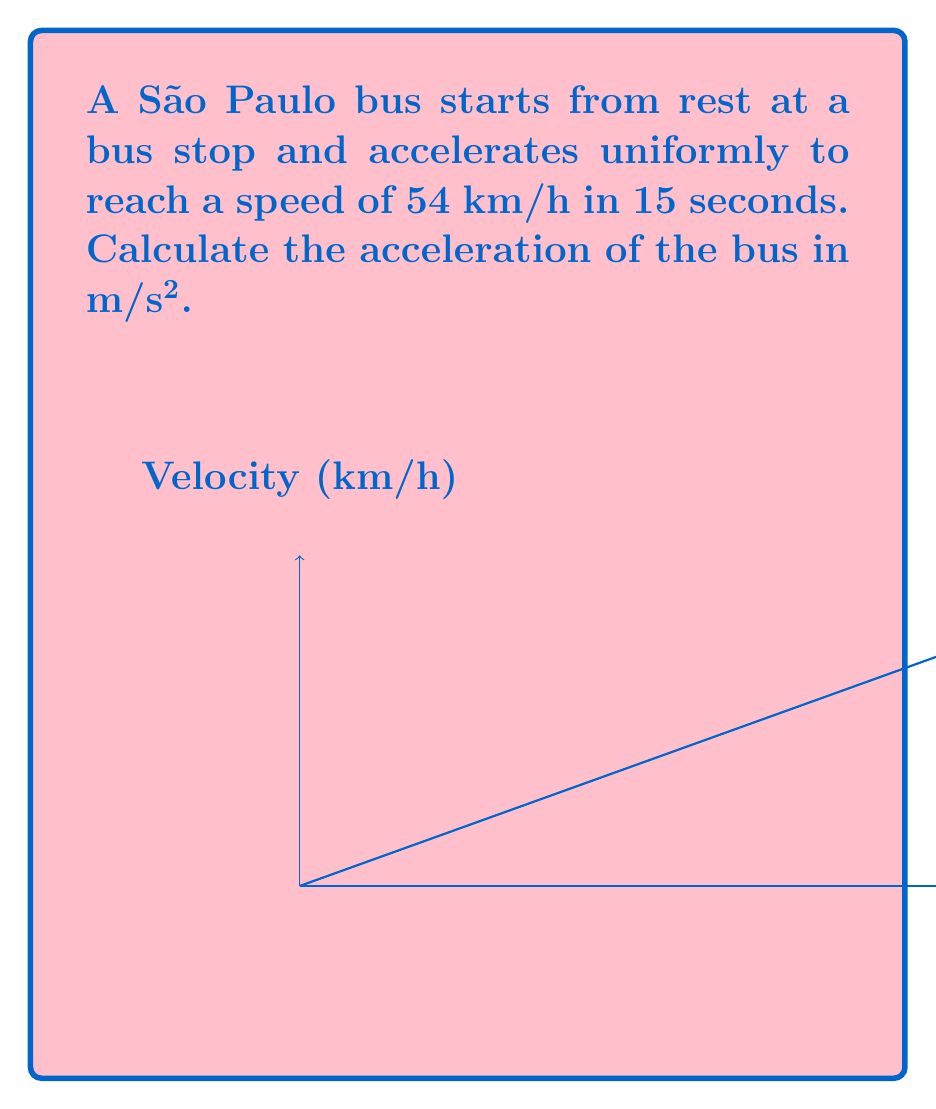Solve this math problem. Let's approach this step-by-step:

1) First, we need to convert the final velocity from km/h to m/s:
   $54 \text{ km/h} = 54 \times \frac{1000 \text{ m}}{3600 \text{ s}} = 15 \text{ m/s}$

2) Now we have:
   - Initial velocity ($v_0$) = 0 m/s (starts from rest)
   - Final velocity ($v$) = 15 m/s
   - Time ($t$) = 15 s

3) We can use the equation for uniform acceleration:
   $a = \frac{v - v_0}{t}$

4) Substituting our values:
   $a = \frac{15 \text{ m/s} - 0 \text{ m/s}}{15 \text{ s}}$

5) Simplifying:
   $a = \frac{15 \text{ m/s}}{15 \text{ s}} = 1 \text{ m/s}^2$

Therefore, the acceleration of the bus is 1 m/s².
Answer: $1 \text{ m/s}^2$ 